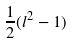Convert formula to latex. <formula><loc_0><loc_0><loc_500><loc_500>\frac { 1 } { 2 } ( l ^ { 2 } - 1 )</formula> 